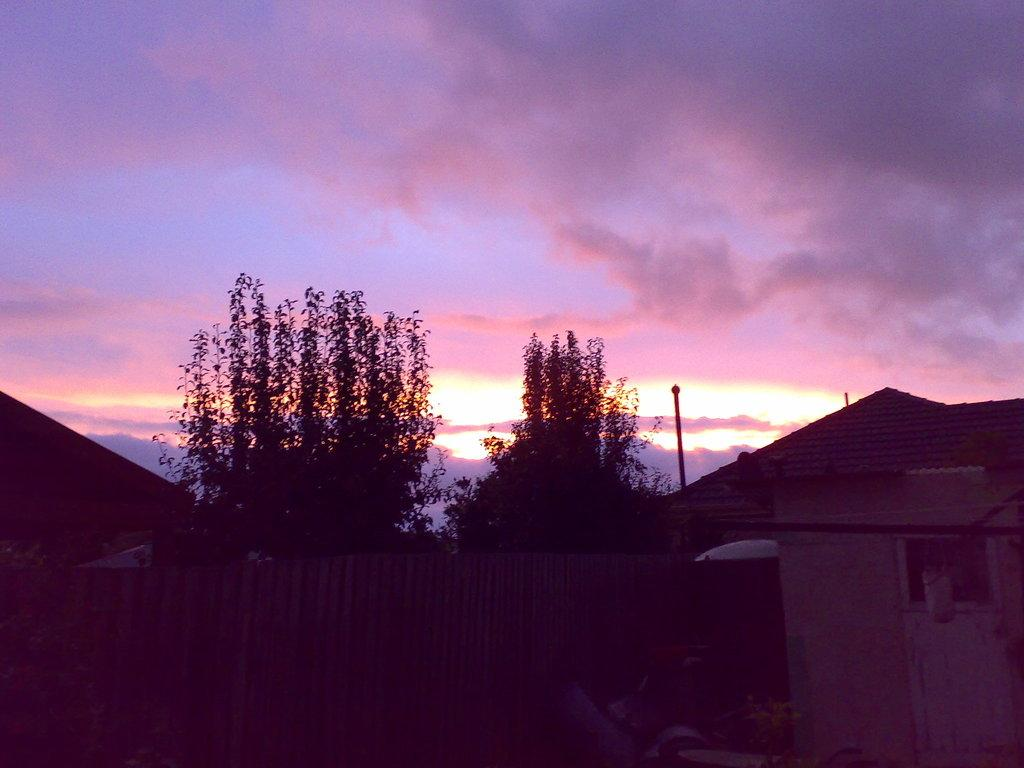What type of structure can be seen in the image? There is fencing in the image. What natural elements are present in the image? There are trees in the image. What man-made structures can be seen in the image? There are houses in the image. What is visible in the background of the image? The sky is visible in the image. How would you describe the sky in the image? The sky appears to be cloudy in the image. How would you describe the overall lighting in the image? The image appears to be slightly dark. How many rings are visible on the orange in the image? There is no orange or rings present in the image. What type of pan is being used to cook the food in the image? There is no pan or food being cooked in the image. 